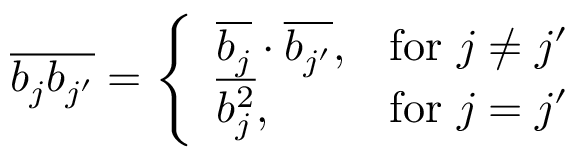<formula> <loc_0><loc_0><loc_500><loc_500>\begin{array} { r } { \overline { { b _ { j } b _ { j ^ { \prime } } } } = \left \{ \begin{array} { l l } { \overline { { b _ { j } } } \cdot \overline { { b _ { j ^ { \prime } } } } , } & { f o r \ j \ne j ^ { \prime } } \\ { \overline { { b _ { j } ^ { 2 } } } , } & { f o r \ j = j ^ { \prime } } \end{array} } \end{array}</formula> 